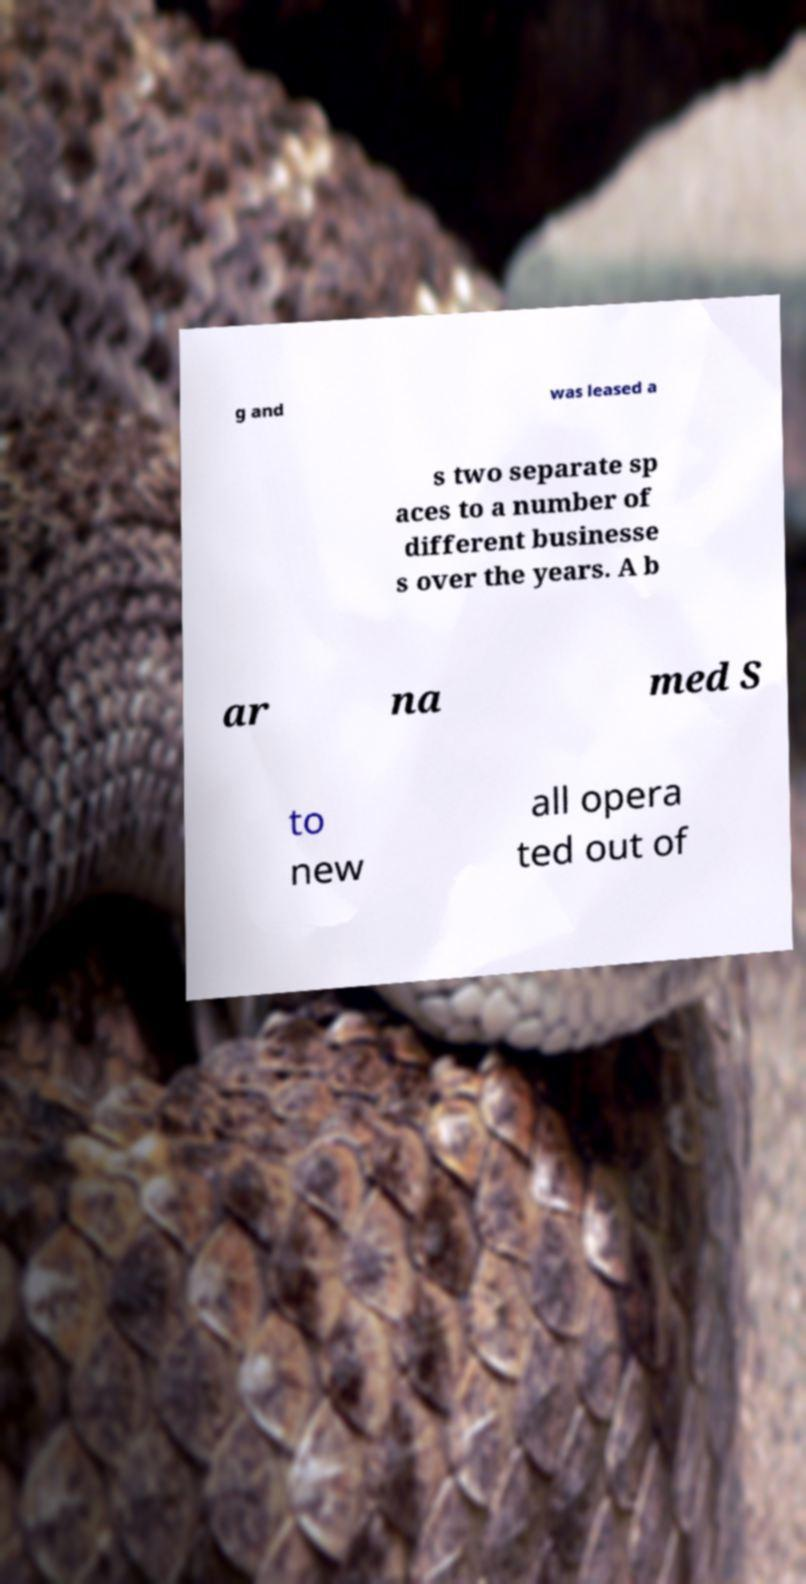I need the written content from this picture converted into text. Can you do that? g and was leased a s two separate sp aces to a number of different businesse s over the years. A b ar na med S to new all opera ted out of 